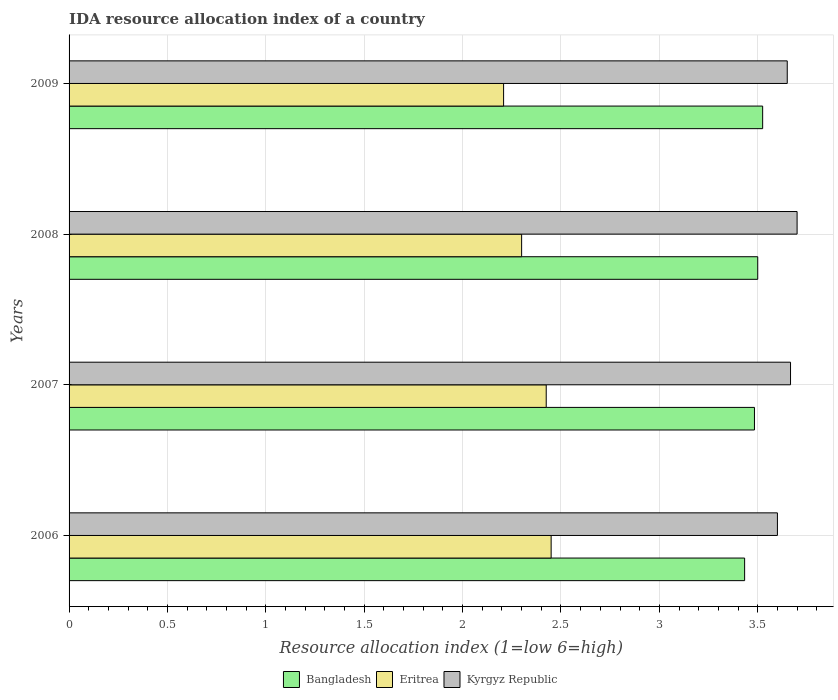Are the number of bars per tick equal to the number of legend labels?
Ensure brevity in your answer.  Yes. Are the number of bars on each tick of the Y-axis equal?
Offer a terse response. Yes. How many bars are there on the 3rd tick from the top?
Make the answer very short. 3. What is the label of the 1st group of bars from the top?
Your answer should be compact. 2009. What is the IDA resource allocation index in Eritrea in 2009?
Your answer should be compact. 2.21. Across all years, what is the maximum IDA resource allocation index in Eritrea?
Offer a terse response. 2.45. Across all years, what is the minimum IDA resource allocation index in Bangladesh?
Your answer should be compact. 3.43. In which year was the IDA resource allocation index in Eritrea minimum?
Offer a very short reply. 2009. What is the total IDA resource allocation index in Kyrgyz Republic in the graph?
Offer a terse response. 14.62. What is the difference between the IDA resource allocation index in Eritrea in 2006 and that in 2007?
Your answer should be compact. 0.03. What is the difference between the IDA resource allocation index in Kyrgyz Republic in 2006 and the IDA resource allocation index in Eritrea in 2007?
Your answer should be very brief. 1.18. What is the average IDA resource allocation index in Kyrgyz Republic per year?
Your answer should be very brief. 3.65. In the year 2007, what is the difference between the IDA resource allocation index in Kyrgyz Republic and IDA resource allocation index in Bangladesh?
Keep it short and to the point. 0.18. What is the ratio of the IDA resource allocation index in Eritrea in 2007 to that in 2009?
Offer a very short reply. 1.1. Is the IDA resource allocation index in Kyrgyz Republic in 2006 less than that in 2007?
Offer a very short reply. Yes. Is the difference between the IDA resource allocation index in Kyrgyz Republic in 2008 and 2009 greater than the difference between the IDA resource allocation index in Bangladesh in 2008 and 2009?
Your response must be concise. Yes. What is the difference between the highest and the second highest IDA resource allocation index in Kyrgyz Republic?
Provide a short and direct response. 0.03. What is the difference between the highest and the lowest IDA resource allocation index in Kyrgyz Republic?
Your response must be concise. 0.1. Is the sum of the IDA resource allocation index in Bangladesh in 2007 and 2009 greater than the maximum IDA resource allocation index in Eritrea across all years?
Offer a very short reply. Yes. What does the 2nd bar from the top in 2007 represents?
Your response must be concise. Eritrea. Is it the case that in every year, the sum of the IDA resource allocation index in Kyrgyz Republic and IDA resource allocation index in Eritrea is greater than the IDA resource allocation index in Bangladesh?
Your response must be concise. Yes. How many bars are there?
Offer a very short reply. 12. Are all the bars in the graph horizontal?
Offer a very short reply. Yes. What is the difference between two consecutive major ticks on the X-axis?
Keep it short and to the point. 0.5. What is the title of the graph?
Your answer should be very brief. IDA resource allocation index of a country. What is the label or title of the X-axis?
Provide a short and direct response. Resource allocation index (1=low 6=high). What is the label or title of the Y-axis?
Provide a succinct answer. Years. What is the Resource allocation index (1=low 6=high) of Bangladesh in 2006?
Offer a very short reply. 3.43. What is the Resource allocation index (1=low 6=high) of Eritrea in 2006?
Your answer should be compact. 2.45. What is the Resource allocation index (1=low 6=high) in Kyrgyz Republic in 2006?
Your answer should be compact. 3.6. What is the Resource allocation index (1=low 6=high) of Bangladesh in 2007?
Provide a short and direct response. 3.48. What is the Resource allocation index (1=low 6=high) of Eritrea in 2007?
Provide a succinct answer. 2.42. What is the Resource allocation index (1=low 6=high) in Kyrgyz Republic in 2007?
Make the answer very short. 3.67. What is the Resource allocation index (1=low 6=high) of Bangladesh in 2008?
Offer a terse response. 3.5. What is the Resource allocation index (1=low 6=high) in Bangladesh in 2009?
Offer a terse response. 3.52. What is the Resource allocation index (1=low 6=high) of Eritrea in 2009?
Keep it short and to the point. 2.21. What is the Resource allocation index (1=low 6=high) of Kyrgyz Republic in 2009?
Keep it short and to the point. 3.65. Across all years, what is the maximum Resource allocation index (1=low 6=high) of Bangladesh?
Ensure brevity in your answer.  3.52. Across all years, what is the maximum Resource allocation index (1=low 6=high) in Eritrea?
Provide a short and direct response. 2.45. Across all years, what is the minimum Resource allocation index (1=low 6=high) of Bangladesh?
Offer a terse response. 3.43. Across all years, what is the minimum Resource allocation index (1=low 6=high) in Eritrea?
Make the answer very short. 2.21. What is the total Resource allocation index (1=low 6=high) in Bangladesh in the graph?
Ensure brevity in your answer.  13.94. What is the total Resource allocation index (1=low 6=high) in Eritrea in the graph?
Your answer should be compact. 9.38. What is the total Resource allocation index (1=low 6=high) in Kyrgyz Republic in the graph?
Provide a short and direct response. 14.62. What is the difference between the Resource allocation index (1=low 6=high) of Bangladesh in 2006 and that in 2007?
Keep it short and to the point. -0.05. What is the difference between the Resource allocation index (1=low 6=high) of Eritrea in 2006 and that in 2007?
Give a very brief answer. 0.03. What is the difference between the Resource allocation index (1=low 6=high) of Kyrgyz Republic in 2006 and that in 2007?
Provide a succinct answer. -0.07. What is the difference between the Resource allocation index (1=low 6=high) in Bangladesh in 2006 and that in 2008?
Your answer should be compact. -0.07. What is the difference between the Resource allocation index (1=low 6=high) of Eritrea in 2006 and that in 2008?
Provide a succinct answer. 0.15. What is the difference between the Resource allocation index (1=low 6=high) of Bangladesh in 2006 and that in 2009?
Keep it short and to the point. -0.09. What is the difference between the Resource allocation index (1=low 6=high) of Eritrea in 2006 and that in 2009?
Give a very brief answer. 0.24. What is the difference between the Resource allocation index (1=low 6=high) of Bangladesh in 2007 and that in 2008?
Offer a very short reply. -0.02. What is the difference between the Resource allocation index (1=low 6=high) in Kyrgyz Republic in 2007 and that in 2008?
Your answer should be very brief. -0.03. What is the difference between the Resource allocation index (1=low 6=high) in Bangladesh in 2007 and that in 2009?
Provide a succinct answer. -0.04. What is the difference between the Resource allocation index (1=low 6=high) of Eritrea in 2007 and that in 2009?
Ensure brevity in your answer.  0.22. What is the difference between the Resource allocation index (1=low 6=high) in Kyrgyz Republic in 2007 and that in 2009?
Make the answer very short. 0.02. What is the difference between the Resource allocation index (1=low 6=high) in Bangladesh in 2008 and that in 2009?
Your response must be concise. -0.03. What is the difference between the Resource allocation index (1=low 6=high) in Eritrea in 2008 and that in 2009?
Make the answer very short. 0.09. What is the difference between the Resource allocation index (1=low 6=high) in Bangladesh in 2006 and the Resource allocation index (1=low 6=high) in Eritrea in 2007?
Your response must be concise. 1.01. What is the difference between the Resource allocation index (1=low 6=high) of Bangladesh in 2006 and the Resource allocation index (1=low 6=high) of Kyrgyz Republic in 2007?
Make the answer very short. -0.23. What is the difference between the Resource allocation index (1=low 6=high) of Eritrea in 2006 and the Resource allocation index (1=low 6=high) of Kyrgyz Republic in 2007?
Make the answer very short. -1.22. What is the difference between the Resource allocation index (1=low 6=high) in Bangladesh in 2006 and the Resource allocation index (1=low 6=high) in Eritrea in 2008?
Provide a succinct answer. 1.13. What is the difference between the Resource allocation index (1=low 6=high) of Bangladesh in 2006 and the Resource allocation index (1=low 6=high) of Kyrgyz Republic in 2008?
Offer a very short reply. -0.27. What is the difference between the Resource allocation index (1=low 6=high) of Eritrea in 2006 and the Resource allocation index (1=low 6=high) of Kyrgyz Republic in 2008?
Offer a terse response. -1.25. What is the difference between the Resource allocation index (1=low 6=high) in Bangladesh in 2006 and the Resource allocation index (1=low 6=high) in Eritrea in 2009?
Provide a succinct answer. 1.23. What is the difference between the Resource allocation index (1=low 6=high) in Bangladesh in 2006 and the Resource allocation index (1=low 6=high) in Kyrgyz Republic in 2009?
Your answer should be very brief. -0.22. What is the difference between the Resource allocation index (1=low 6=high) in Bangladesh in 2007 and the Resource allocation index (1=low 6=high) in Eritrea in 2008?
Your answer should be compact. 1.18. What is the difference between the Resource allocation index (1=low 6=high) of Bangladesh in 2007 and the Resource allocation index (1=low 6=high) of Kyrgyz Republic in 2008?
Give a very brief answer. -0.22. What is the difference between the Resource allocation index (1=low 6=high) in Eritrea in 2007 and the Resource allocation index (1=low 6=high) in Kyrgyz Republic in 2008?
Your answer should be compact. -1.27. What is the difference between the Resource allocation index (1=low 6=high) of Bangladesh in 2007 and the Resource allocation index (1=low 6=high) of Eritrea in 2009?
Offer a terse response. 1.27. What is the difference between the Resource allocation index (1=low 6=high) of Bangladesh in 2007 and the Resource allocation index (1=low 6=high) of Kyrgyz Republic in 2009?
Provide a short and direct response. -0.17. What is the difference between the Resource allocation index (1=low 6=high) of Eritrea in 2007 and the Resource allocation index (1=low 6=high) of Kyrgyz Republic in 2009?
Your answer should be very brief. -1.23. What is the difference between the Resource allocation index (1=low 6=high) in Bangladesh in 2008 and the Resource allocation index (1=low 6=high) in Eritrea in 2009?
Keep it short and to the point. 1.29. What is the difference between the Resource allocation index (1=low 6=high) of Bangladesh in 2008 and the Resource allocation index (1=low 6=high) of Kyrgyz Republic in 2009?
Provide a short and direct response. -0.15. What is the difference between the Resource allocation index (1=low 6=high) in Eritrea in 2008 and the Resource allocation index (1=low 6=high) in Kyrgyz Republic in 2009?
Ensure brevity in your answer.  -1.35. What is the average Resource allocation index (1=low 6=high) of Bangladesh per year?
Provide a succinct answer. 3.49. What is the average Resource allocation index (1=low 6=high) in Eritrea per year?
Give a very brief answer. 2.35. What is the average Resource allocation index (1=low 6=high) in Kyrgyz Republic per year?
Provide a short and direct response. 3.65. In the year 2006, what is the difference between the Resource allocation index (1=low 6=high) in Bangladesh and Resource allocation index (1=low 6=high) in Eritrea?
Provide a short and direct response. 0.98. In the year 2006, what is the difference between the Resource allocation index (1=low 6=high) in Eritrea and Resource allocation index (1=low 6=high) in Kyrgyz Republic?
Provide a short and direct response. -1.15. In the year 2007, what is the difference between the Resource allocation index (1=low 6=high) in Bangladesh and Resource allocation index (1=low 6=high) in Eritrea?
Give a very brief answer. 1.06. In the year 2007, what is the difference between the Resource allocation index (1=low 6=high) in Bangladesh and Resource allocation index (1=low 6=high) in Kyrgyz Republic?
Your answer should be compact. -0.18. In the year 2007, what is the difference between the Resource allocation index (1=low 6=high) of Eritrea and Resource allocation index (1=low 6=high) of Kyrgyz Republic?
Keep it short and to the point. -1.24. In the year 2008, what is the difference between the Resource allocation index (1=low 6=high) in Bangladesh and Resource allocation index (1=low 6=high) in Eritrea?
Give a very brief answer. 1.2. In the year 2008, what is the difference between the Resource allocation index (1=low 6=high) of Bangladesh and Resource allocation index (1=low 6=high) of Kyrgyz Republic?
Make the answer very short. -0.2. In the year 2009, what is the difference between the Resource allocation index (1=low 6=high) in Bangladesh and Resource allocation index (1=low 6=high) in Eritrea?
Offer a terse response. 1.32. In the year 2009, what is the difference between the Resource allocation index (1=low 6=high) of Bangladesh and Resource allocation index (1=low 6=high) of Kyrgyz Republic?
Provide a short and direct response. -0.12. In the year 2009, what is the difference between the Resource allocation index (1=low 6=high) in Eritrea and Resource allocation index (1=low 6=high) in Kyrgyz Republic?
Your response must be concise. -1.44. What is the ratio of the Resource allocation index (1=low 6=high) in Bangladesh in 2006 to that in 2007?
Provide a succinct answer. 0.99. What is the ratio of the Resource allocation index (1=low 6=high) of Eritrea in 2006 to that in 2007?
Provide a succinct answer. 1.01. What is the ratio of the Resource allocation index (1=low 6=high) in Kyrgyz Republic in 2006 to that in 2007?
Provide a short and direct response. 0.98. What is the ratio of the Resource allocation index (1=low 6=high) of Eritrea in 2006 to that in 2008?
Offer a very short reply. 1.07. What is the ratio of the Resource allocation index (1=low 6=high) of Eritrea in 2006 to that in 2009?
Your answer should be very brief. 1.11. What is the ratio of the Resource allocation index (1=low 6=high) of Kyrgyz Republic in 2006 to that in 2009?
Provide a succinct answer. 0.99. What is the ratio of the Resource allocation index (1=low 6=high) in Eritrea in 2007 to that in 2008?
Provide a succinct answer. 1.05. What is the ratio of the Resource allocation index (1=low 6=high) in Bangladesh in 2007 to that in 2009?
Your answer should be very brief. 0.99. What is the ratio of the Resource allocation index (1=low 6=high) of Eritrea in 2007 to that in 2009?
Offer a very short reply. 1.1. What is the ratio of the Resource allocation index (1=low 6=high) of Kyrgyz Republic in 2007 to that in 2009?
Ensure brevity in your answer.  1. What is the ratio of the Resource allocation index (1=low 6=high) in Bangladesh in 2008 to that in 2009?
Your answer should be compact. 0.99. What is the ratio of the Resource allocation index (1=low 6=high) of Eritrea in 2008 to that in 2009?
Make the answer very short. 1.04. What is the ratio of the Resource allocation index (1=low 6=high) in Kyrgyz Republic in 2008 to that in 2009?
Ensure brevity in your answer.  1.01. What is the difference between the highest and the second highest Resource allocation index (1=low 6=high) in Bangladesh?
Your answer should be compact. 0.03. What is the difference between the highest and the second highest Resource allocation index (1=low 6=high) of Eritrea?
Offer a very short reply. 0.03. What is the difference between the highest and the lowest Resource allocation index (1=low 6=high) in Bangladesh?
Provide a succinct answer. 0.09. What is the difference between the highest and the lowest Resource allocation index (1=low 6=high) of Eritrea?
Offer a terse response. 0.24. 